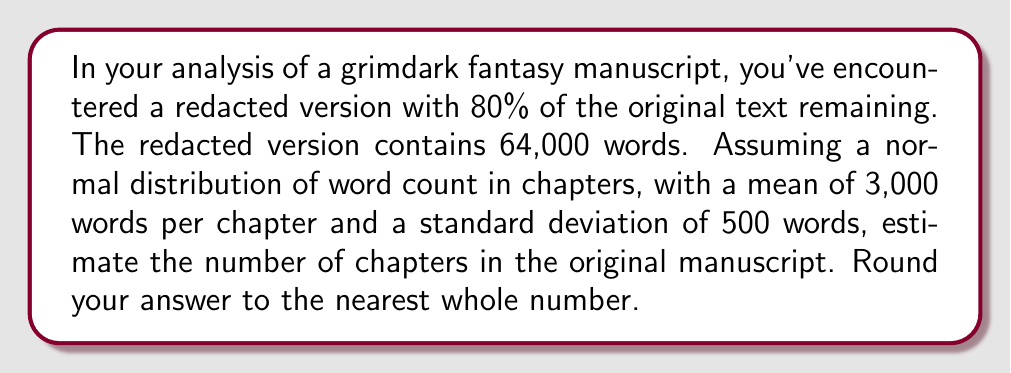Give your solution to this math problem. Let's approach this step-by-step:

1) First, we need to estimate the total word count of the original manuscript:
   If 80% remains, then:
   $$64,000 = 0.8x$$
   where $x$ is the original word count.
   
   Solving for $x$:
   $$x = \frac{64,000}{0.8} = 80,000$$ words in the original manuscript.

2) Now, we need to estimate the number of chapters. We're told that chapters follow a normal distribution with:
   $\mu = 3,000$ words (mean)
   $\sigma = 500$ words (standard deviation)

3) The number of chapters can be estimated by dividing the total word count by the mean words per chapter:
   $$\text{Estimated chapters} = \frac{\text{Total words}}{\text{Mean words per chapter}}$$

4) Plugging in our values:
   $$\text{Estimated chapters} = \frac{80,000}{3,000} = 26.67$$

5) Rounding to the nearest whole number:
   $$\text{Estimated chapters} \approx 27$$

This method provides a point estimate. In a more advanced analysis, we could provide a confidence interval using the standard deviation, but that's beyond the scope of this estimation.
Answer: 27 chapters 